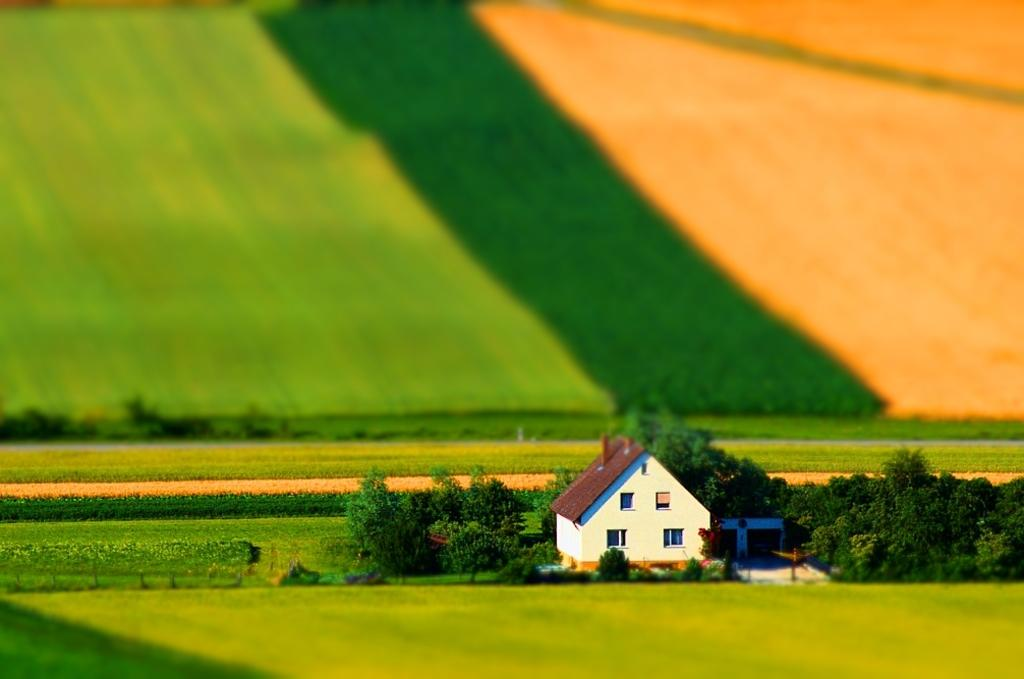What is the main structure in the middle of the image? There is a small shed house in the middle of the image. What can be seen beside the shed house? There are trees beside the shed house. What type of landscape is visible behind the shed house? There is a farm visible behind the shed house. How many rabbits can be seen in the crowd in the image? There are no rabbits or crowds present in the image. 